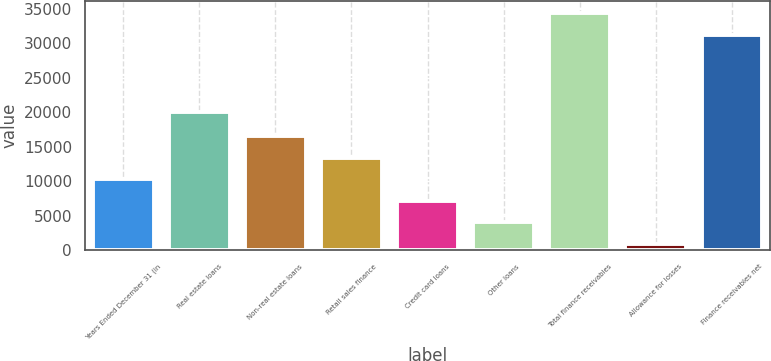Convert chart. <chart><loc_0><loc_0><loc_500><loc_500><bar_chart><fcel>Years Ended December 31 (in<fcel>Real estate loans<fcel>Non-real estate loans<fcel>Retail sales finance<fcel>Credit card loans<fcel>Other loans<fcel>Total finance receivables<fcel>Allowance for losses<fcel>Finance receivables net<nl><fcel>10248.2<fcel>20023<fcel>16495<fcel>13371.6<fcel>7124.8<fcel>4001.4<fcel>34357.4<fcel>878<fcel>31234<nl></chart> 